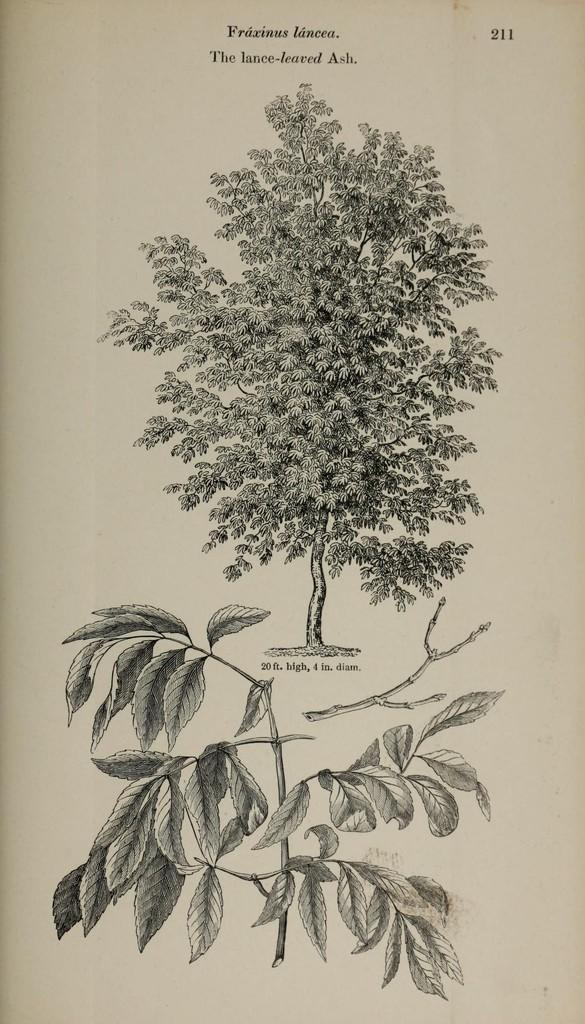What type of vegetation can be seen in the image? There are branches and a tree in the image. What is the main subject of the image? The main subject of the image is a tree. What else is present in the image besides the tree? There is text on a page in the image. How does the ground appear to be increasing in the image? The ground is not increasing in the image; it remains stationary. The image only shows a tree, branches, and text on a page. 